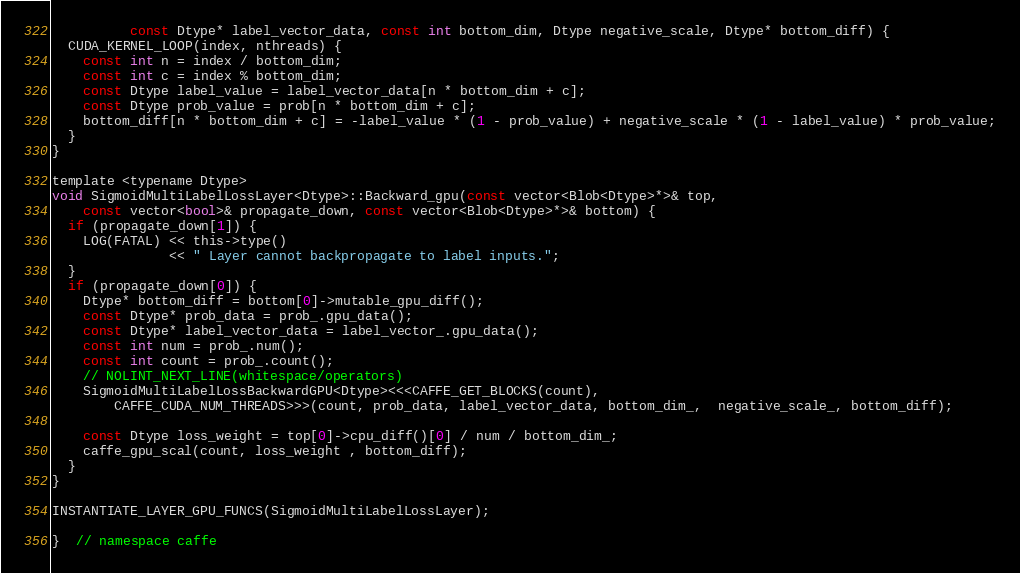Convert code to text. <code><loc_0><loc_0><loc_500><loc_500><_Cuda_>          const Dtype* label_vector_data, const int bottom_dim, Dtype negative_scale, Dtype* bottom_diff) {
  CUDA_KERNEL_LOOP(index, nthreads) {
    const int n = index / bottom_dim;
    const int c = index % bottom_dim;
    const Dtype label_value = label_vector_data[n * bottom_dim + c];
    const Dtype prob_value = prob[n * bottom_dim + c];
    bottom_diff[n * bottom_dim + c] = -label_value * (1 - prob_value) + negative_scale * (1 - label_value) * prob_value;
  }
}

template <typename Dtype>
void SigmoidMultiLabelLossLayer<Dtype>::Backward_gpu(const vector<Blob<Dtype>*>& top,
    const vector<bool>& propagate_down, const vector<Blob<Dtype>*>& bottom) {
  if (propagate_down[1]) {
    LOG(FATAL) << this->type()
               << " Layer cannot backpropagate to label inputs.";
  }
  if (propagate_down[0]) {
    Dtype* bottom_diff = bottom[0]->mutable_gpu_diff();
    const Dtype* prob_data = prob_.gpu_data();
    const Dtype* label_vector_data = label_vector_.gpu_data();
    const int num = prob_.num(); 
    const int count = prob_.count();
    // NOLINT_NEXT_LINE(whitespace/operators)
    SigmoidMultiLabelLossBackwardGPU<Dtype><<<CAFFE_GET_BLOCKS(count),
        CAFFE_CUDA_NUM_THREADS>>>(count, prob_data, label_vector_data, bottom_dim_,  negative_scale_, bottom_diff);

    const Dtype loss_weight = top[0]->cpu_diff()[0] / num / bottom_dim_;
    caffe_gpu_scal(count, loss_weight , bottom_diff);
  }
}

INSTANTIATE_LAYER_GPU_FUNCS(SigmoidMultiLabelLossLayer);

}  // namespace caffe
</code> 